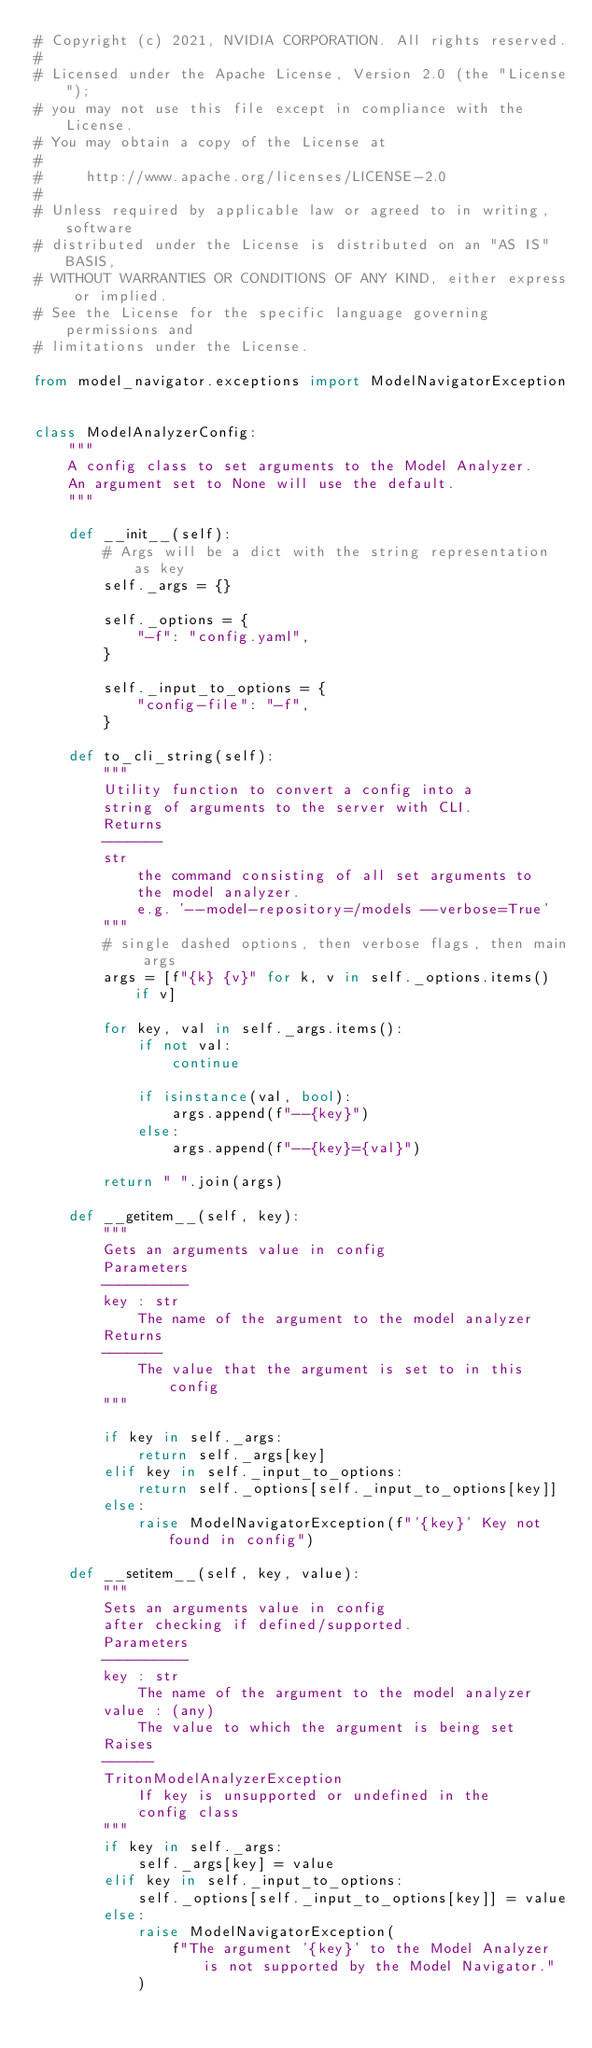Convert code to text. <code><loc_0><loc_0><loc_500><loc_500><_Python_># Copyright (c) 2021, NVIDIA CORPORATION. All rights reserved.
#
# Licensed under the Apache License, Version 2.0 (the "License");
# you may not use this file except in compliance with the License.
# You may obtain a copy of the License at
#
#     http://www.apache.org/licenses/LICENSE-2.0
#
# Unless required by applicable law or agreed to in writing, software
# distributed under the License is distributed on an "AS IS" BASIS,
# WITHOUT WARRANTIES OR CONDITIONS OF ANY KIND, either express or implied.
# See the License for the specific language governing permissions and
# limitations under the License.

from model_navigator.exceptions import ModelNavigatorException


class ModelAnalyzerConfig:
    """
    A config class to set arguments to the Model Analyzer.
    An argument set to None will use the default.
    """

    def __init__(self):
        # Args will be a dict with the string representation as key
        self._args = {}

        self._options = {
            "-f": "config.yaml",
        }

        self._input_to_options = {
            "config-file": "-f",
        }

    def to_cli_string(self):
        """
        Utility function to convert a config into a
        string of arguments to the server with CLI.
        Returns
        -------
        str
            the command consisting of all set arguments to
            the model analyzer.
            e.g. '--model-repository=/models --verbose=True'
        """
        # single dashed options, then verbose flags, then main args
        args = [f"{k} {v}" for k, v in self._options.items() if v]

        for key, val in self._args.items():
            if not val:
                continue

            if isinstance(val, bool):
                args.append(f"--{key}")
            else:
                args.append(f"--{key}={val}")

        return " ".join(args)

    def __getitem__(self, key):
        """
        Gets an arguments value in config
        Parameters
        ----------
        key : str
            The name of the argument to the model analyzer
        Returns
        -------
            The value that the argument is set to in this config
        """

        if key in self._args:
            return self._args[key]
        elif key in self._input_to_options:
            return self._options[self._input_to_options[key]]
        else:
            raise ModelNavigatorException(f"'{key}' Key not found in config")

    def __setitem__(self, key, value):
        """
        Sets an arguments value in config
        after checking if defined/supported.
        Parameters
        ----------
        key : str
            The name of the argument to the model analyzer
        value : (any)
            The value to which the argument is being set
        Raises
        ------
        TritonModelAnalyzerException
            If key is unsupported or undefined in the
            config class
        """
        if key in self._args:
            self._args[key] = value
        elif key in self._input_to_options:
            self._options[self._input_to_options[key]] = value
        else:
            raise ModelNavigatorException(
                f"The argument '{key}' to the Model Analyzer is not supported by the Model Navigator."
            )
</code> 